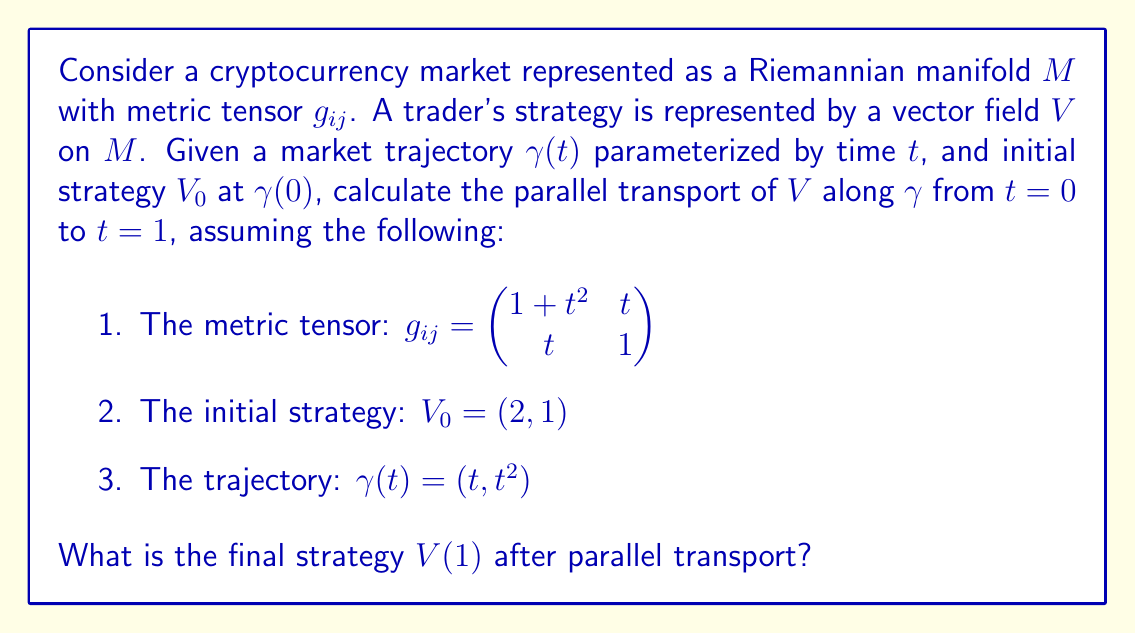Show me your answer to this math problem. To solve this problem, we need to follow these steps:

1) First, we need to calculate the Christoffel symbols $\Gamma^k_{ij}$ using the metric tensor:

   $$\Gamma^k_{ij} = \frac{1}{2}g^{kl}(\partial_i g_{jl} + \partial_j g_{il} - \partial_l g_{ij})$$

2) The inverse metric tensor $g^{ij}$ is:

   $$g^{ij} = \frac{1}{1+t^2-t^2}\begin{pmatrix} 1 & -t \\ -t & 1+t^2 \end{pmatrix} = \begin{pmatrix} 1 & -t \\ -t & 1+t^2 \end{pmatrix}$$

3) Calculating the non-zero Christoffel symbols:

   $$\Gamma^1_{11} = \frac{t}{1+t^2}, \Gamma^1_{12} = \Gamma^1_{21} = \frac{1}{2}, \Gamma^2_{11} = -\frac{t}{2}$$
   $$\Gamma^2_{12} = \Gamma^2_{21} = \frac{t^2}{2(1+t^2)}, \Gamma^2_{22} = \frac{t}{1+t^2}$$

4) The parallel transport equation is:

   $$\frac{dV^i}{dt} + \Gamma^i_{jk}\frac{d\gamma^j}{dt}V^k = 0$$

5) Substituting our trajectory $\gamma(t) = (t, t^2)$, we get:

   $$\frac{dV^1}{dt} + \Gamma^1_{11}V^1 + 2t\Gamma^1_{12}V^2 = 0$$
   $$\frac{dV^2}{dt} + \Gamma^2_{11}V^1 + 2t\Gamma^2_{12}V^2 = 0$$

6) Substituting the Christoffel symbols and simplifying:

   $$\frac{dV^1}{dt} + \frac{t}{1+t^2}V^1 + tV^2 = 0$$
   $$\frac{dV^2}{dt} - \frac{t}{2}V^1 + \frac{t^3}{1+t^2}V^2 = 0$$

7) This is a system of first-order ODEs. We can solve it numerically using a method like Runge-Kutta with the initial condition $V(0) = (2, 1)$.

8) After numerical integration from $t=0$ to $t=1$, we get the final strategy $V(1)$.
Answer: $V(1) \approx (1.62, 1.31)$ 